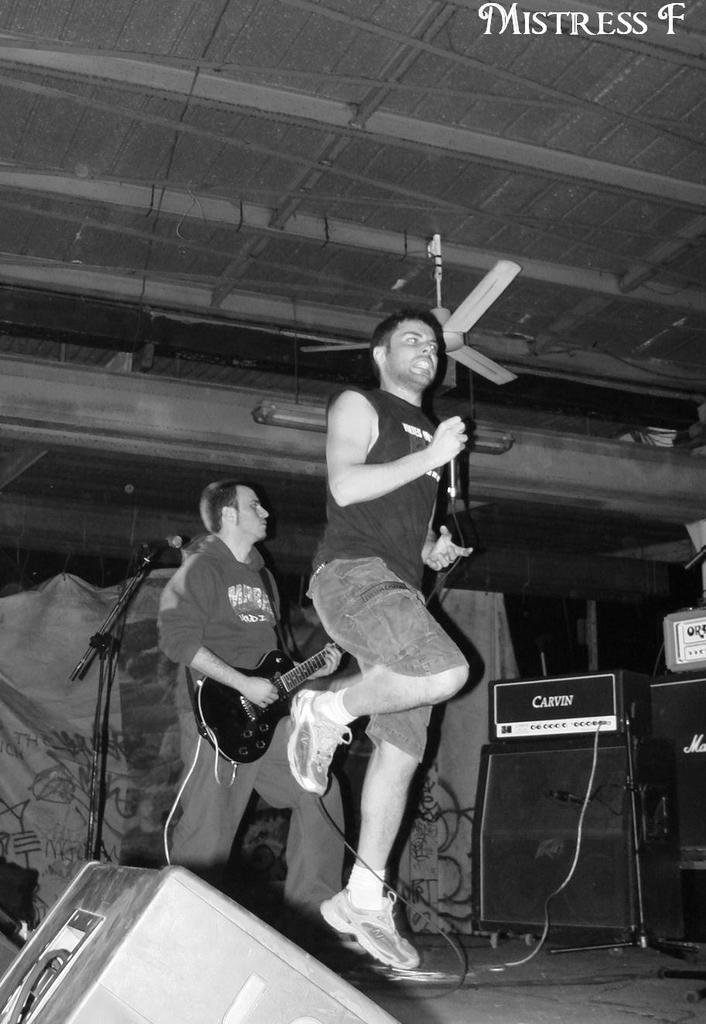Could you give a brief overview of what you see in this image? In the middle a man is playing guitar and here a man is jumping at the top it's a fan. 